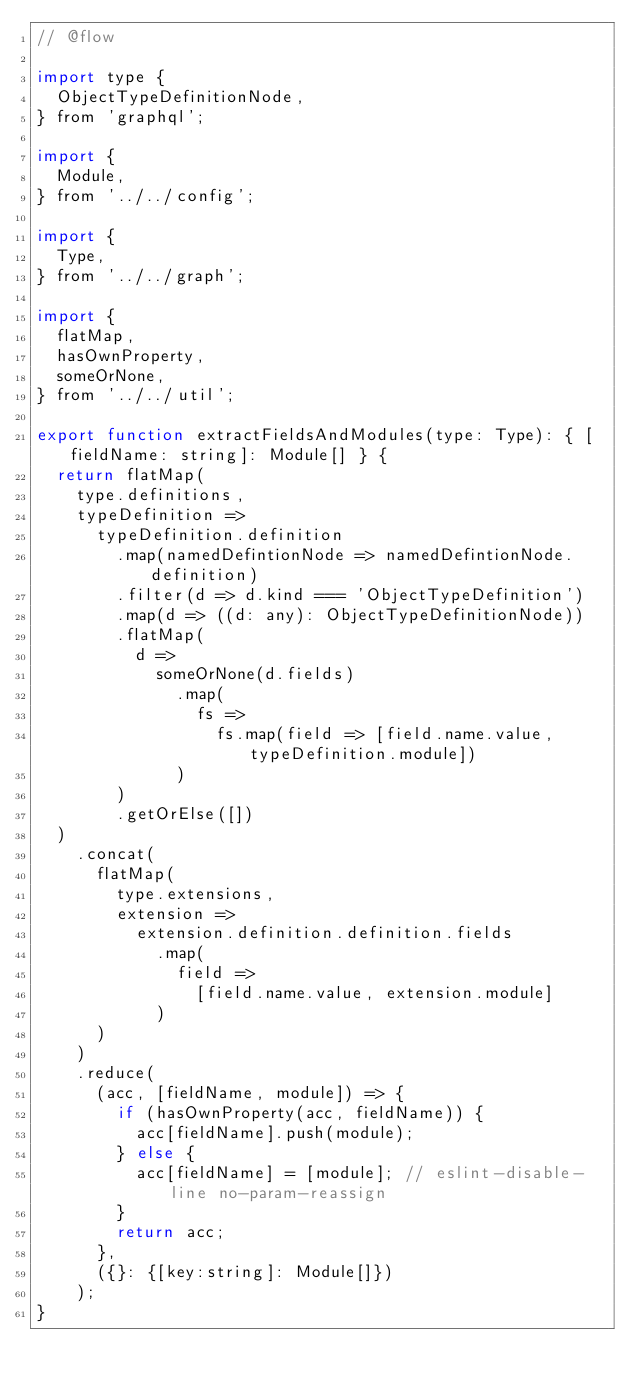<code> <loc_0><loc_0><loc_500><loc_500><_JavaScript_>// @flow

import type {
  ObjectTypeDefinitionNode,
} from 'graphql';

import {
  Module,
} from '../../config';

import {
  Type,
} from '../../graph';

import {
  flatMap,
  hasOwnProperty,
  someOrNone,
} from '../../util';

export function extractFieldsAndModules(type: Type): { [fieldName: string]: Module[] } {
  return flatMap(
    type.definitions,
    typeDefinition =>
      typeDefinition.definition
        .map(namedDefintionNode => namedDefintionNode.definition)
        .filter(d => d.kind === 'ObjectTypeDefinition')
        .map(d => ((d: any): ObjectTypeDefinitionNode))
        .flatMap(
          d =>
            someOrNone(d.fields)
              .map(
                fs =>
                  fs.map(field => [field.name.value, typeDefinition.module])
              )
        )
        .getOrElse([])
  )
    .concat(
      flatMap(
        type.extensions,
        extension =>
          extension.definition.definition.fields
            .map(
              field =>
                [field.name.value, extension.module]
            )
      )
    )
    .reduce(
      (acc, [fieldName, module]) => {
        if (hasOwnProperty(acc, fieldName)) {
          acc[fieldName].push(module);
        } else {
          acc[fieldName] = [module]; // eslint-disable-line no-param-reassign
        }
        return acc;
      },
      ({}: {[key:string]: Module[]})
    );
}
</code> 